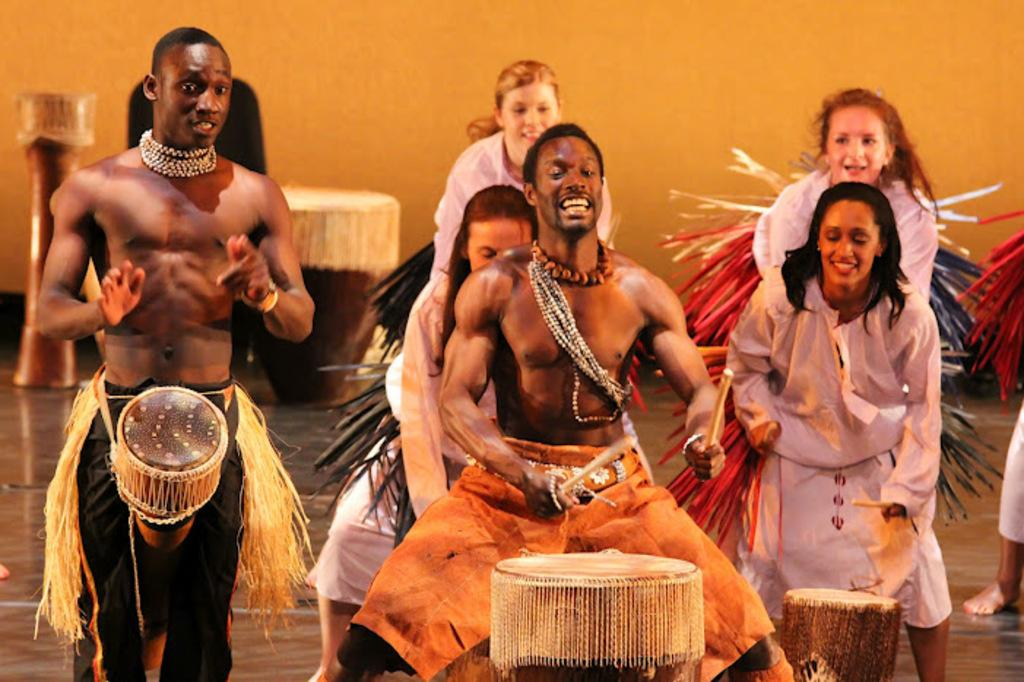How many people are in the image? There are persons in the image. What are the people wearing? The persons are wearing colorful clothes. What activity are the people engaged in? The persons are playing drums. Can you describe the person holding drum sticks? There is a person holding drum sticks in their hands. What object is used for playing the drums? There is a drum in the image. What is behind the persons in the image? There is a wall behind the persons. What type of connection can be seen between the persons and the wheel in the image? There is no wheel present in the image, so there is no connection between the persons and a wheel. 